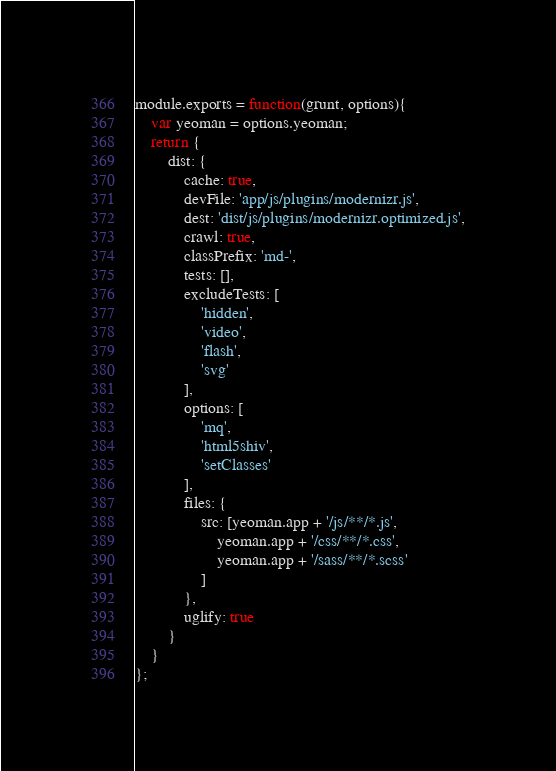Convert code to text. <code><loc_0><loc_0><loc_500><loc_500><_JavaScript_>module.exports = function(grunt, options){
	var yeoman = options.yeoman;
	return {
		dist: {
			cache: true,
			devFile: 'app/js/plugins/modernizr.js',
			dest: 'dist/js/plugins/modernizr.optimized.js',
			crawl: true,
			classPrefix: 'md-',
			tests: [],
			excludeTests: [
				'hidden',
				'video',
				'flash',
				'svg'
			],
			options: [
				'mq',
				'html5shiv',
				'setClasses'
			],
			files: {
				src: [yeoman.app + '/js/**/*.js',
					yeoman.app + '/css/**/*.css',
					yeoman.app + '/sass/**/*.scss'
				]
			},
			uglify: true
		}
	}
};
</code> 